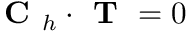Convert formula to latex. <formula><loc_0><loc_0><loc_500><loc_500>C _ { h } \cdot T = 0</formula> 